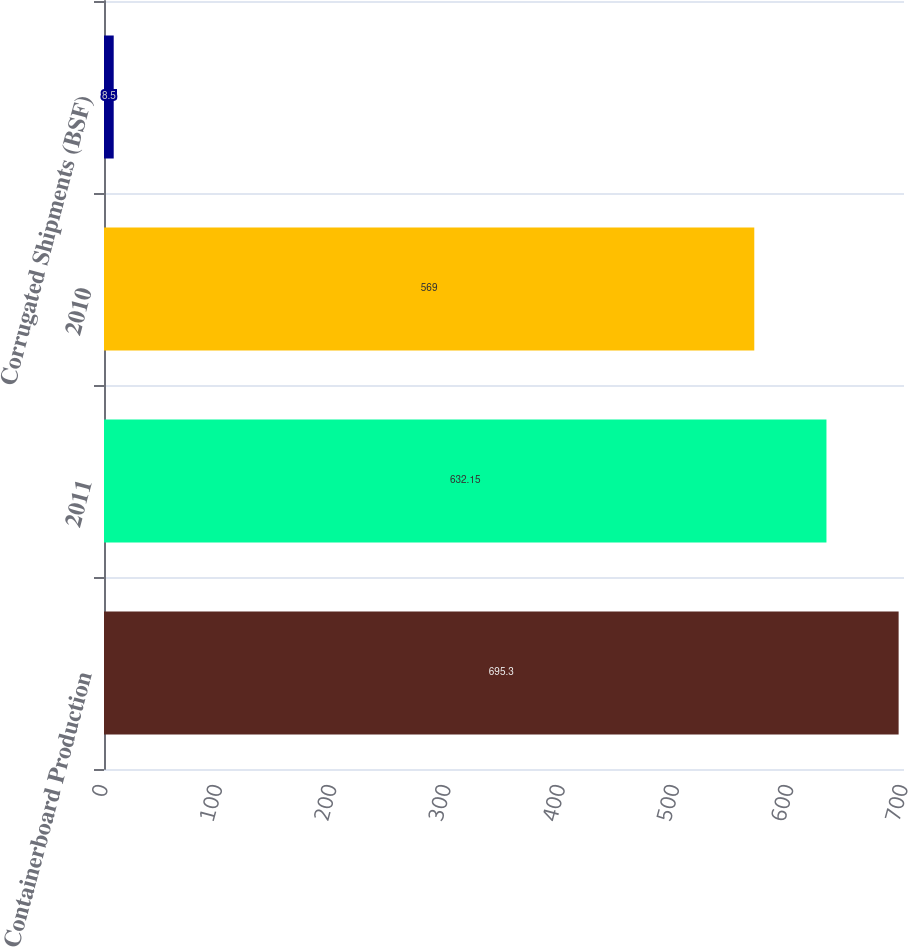<chart> <loc_0><loc_0><loc_500><loc_500><bar_chart><fcel>Containerboard Production<fcel>2011<fcel>2010<fcel>Corrugated Shipments (BSF)<nl><fcel>695.3<fcel>632.15<fcel>569<fcel>8.5<nl></chart> 